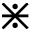Convert formula to latex. <formula><loc_0><loc_0><loc_500><loc_500>\divideontimes</formula> 